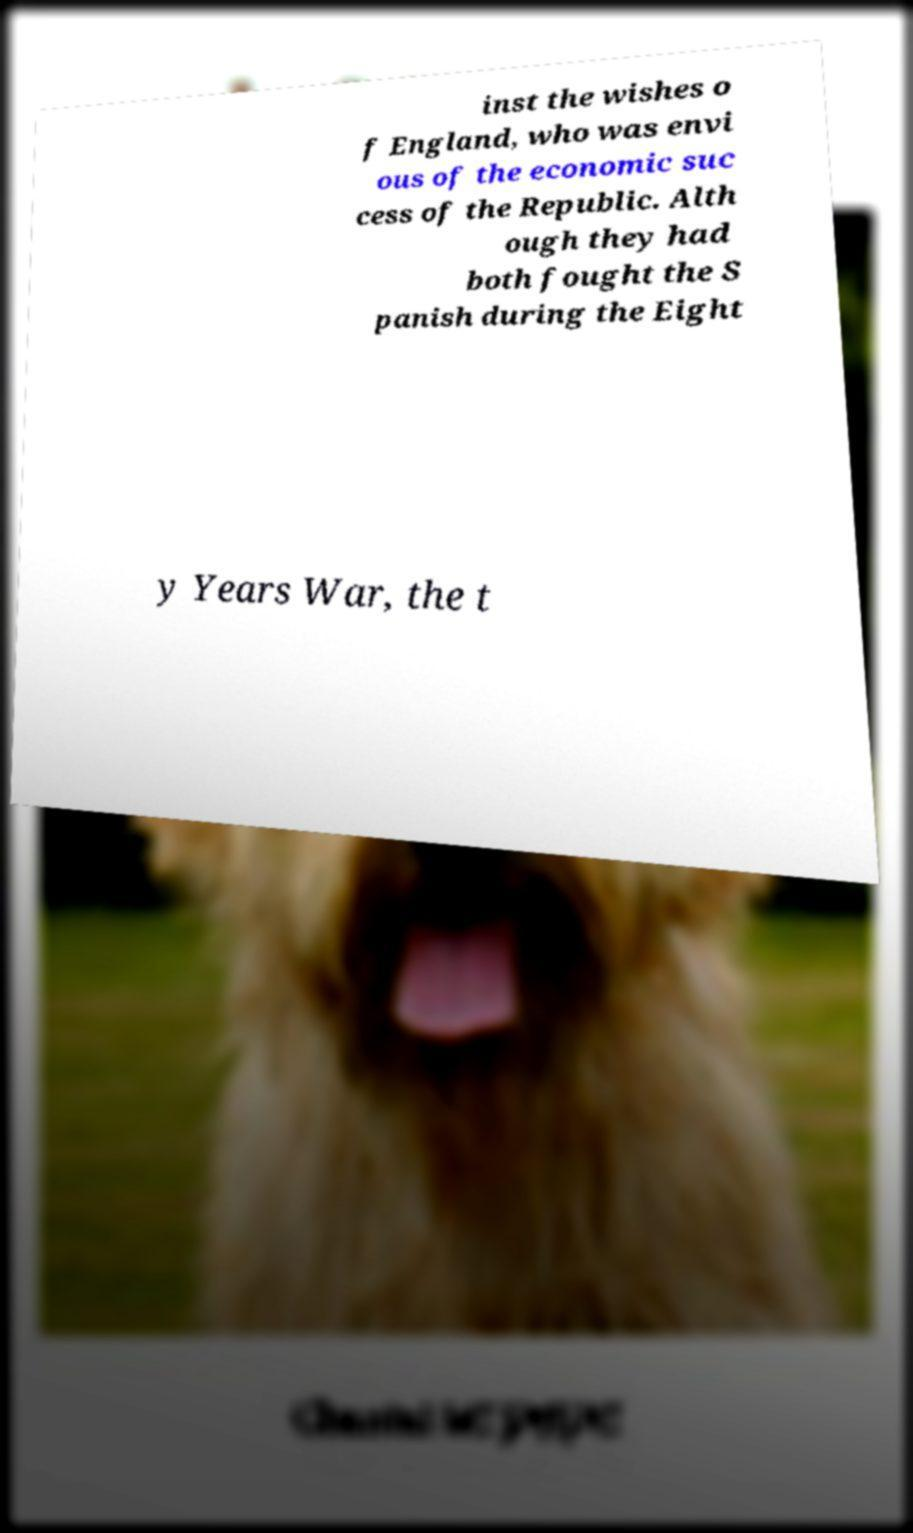There's text embedded in this image that I need extracted. Can you transcribe it verbatim? inst the wishes o f England, who was envi ous of the economic suc cess of the Republic. Alth ough they had both fought the S panish during the Eight y Years War, the t 